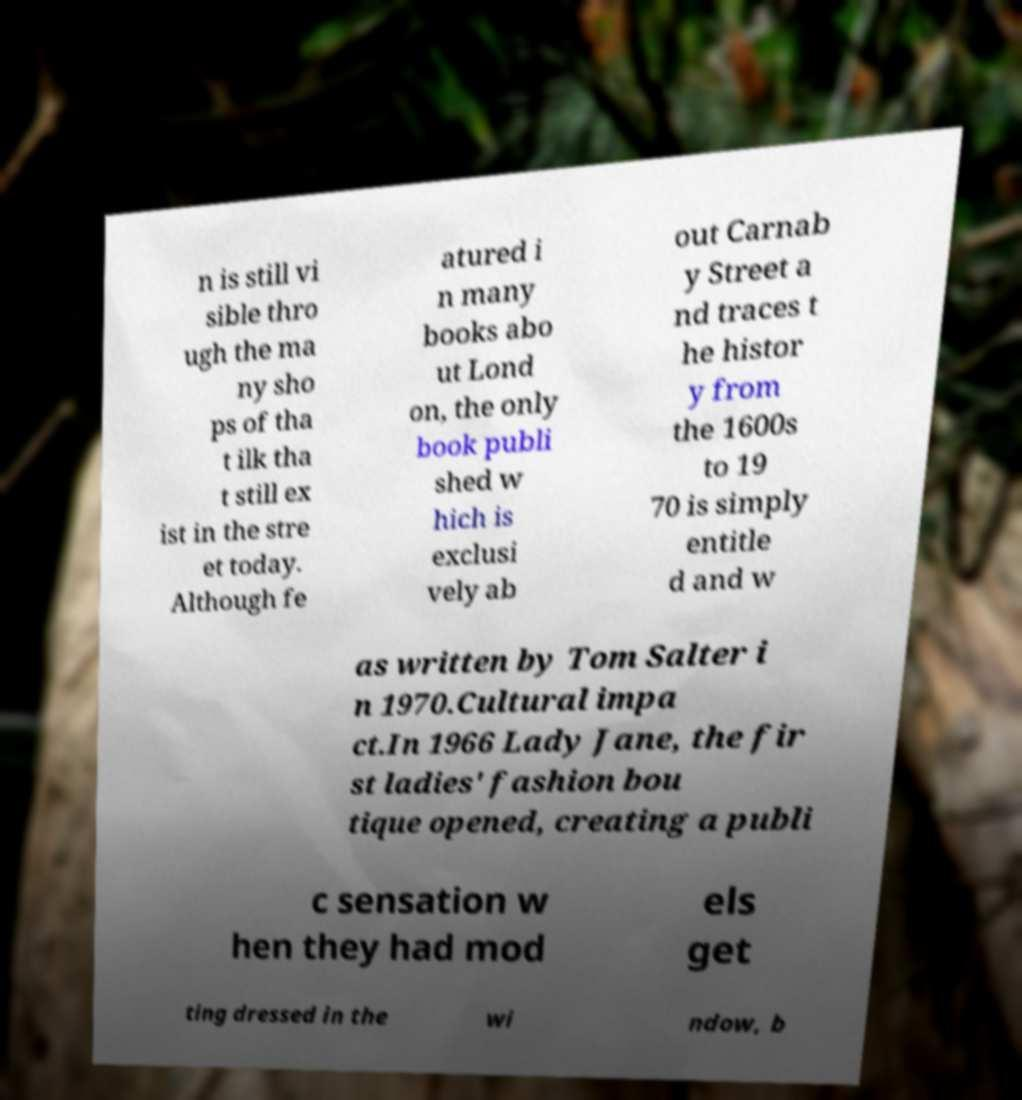Please read and relay the text visible in this image. What does it say? n is still vi sible thro ugh the ma ny sho ps of tha t ilk tha t still ex ist in the stre et today. Although fe atured i n many books abo ut Lond on, the only book publi shed w hich is exclusi vely ab out Carnab y Street a nd traces t he histor y from the 1600s to 19 70 is simply entitle d and w as written by Tom Salter i n 1970.Cultural impa ct.In 1966 Lady Jane, the fir st ladies' fashion bou tique opened, creating a publi c sensation w hen they had mod els get ting dressed in the wi ndow, b 